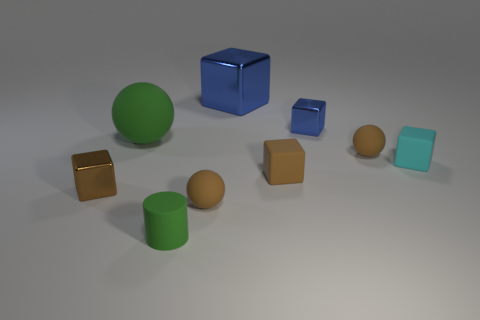Subtract all cyan cubes. How many cubes are left? 4 Subtract all big blue blocks. How many blocks are left? 4 Subtract all purple blocks. Subtract all yellow cylinders. How many blocks are left? 5 Add 1 small yellow blocks. How many objects exist? 10 Subtract all cubes. How many objects are left? 4 Subtract 1 cyan cubes. How many objects are left? 8 Subtract all big green matte spheres. Subtract all small metallic cylinders. How many objects are left? 8 Add 6 small spheres. How many small spheres are left? 8 Add 6 brown cubes. How many brown cubes exist? 8 